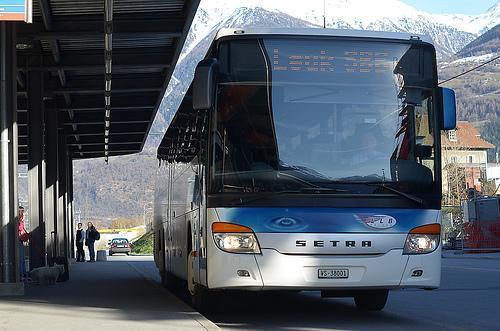How many people are visible?
Give a very brief answer. 4. How many vehicles are in the photo?
Give a very brief answer. 2. How many headlights are on the left half of the bus grille?
Give a very brief answer. 1. 